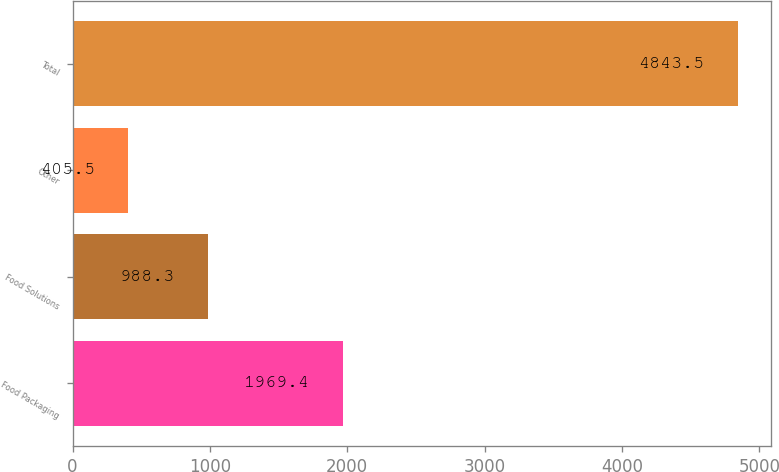Convert chart to OTSL. <chart><loc_0><loc_0><loc_500><loc_500><bar_chart><fcel>Food Packaging<fcel>Food Solutions<fcel>Other<fcel>Total<nl><fcel>1969.4<fcel>988.3<fcel>405.5<fcel>4843.5<nl></chart> 